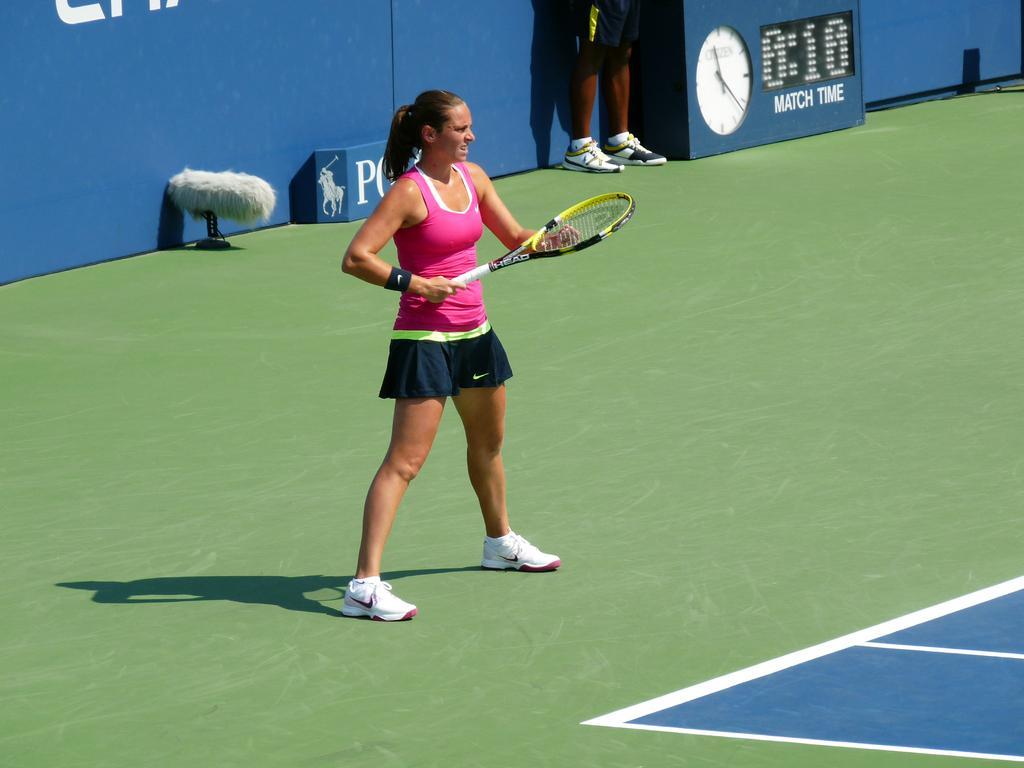Describe this image in one or two sentences. This picture shows a woman playing tennis with a racket 